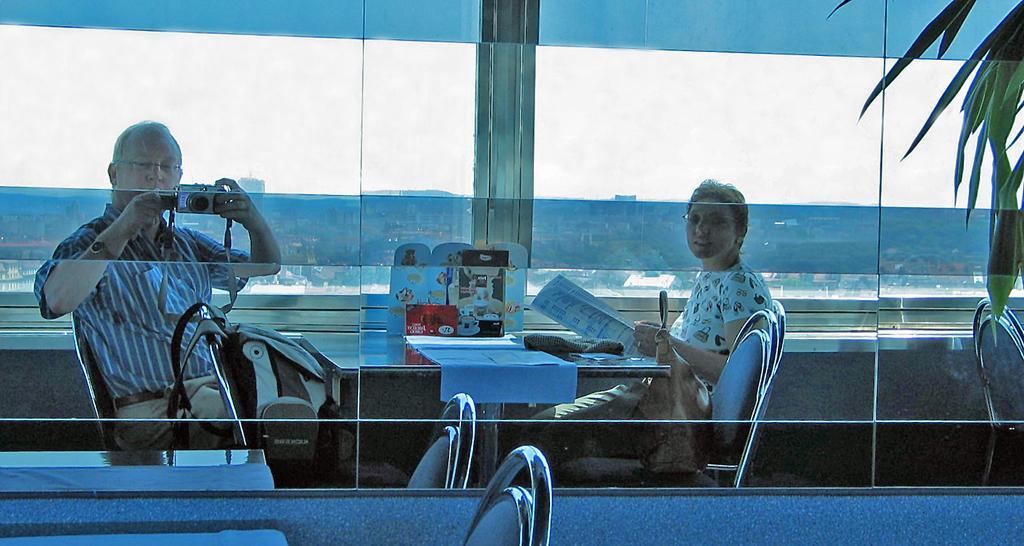Please provide a concise description of this image. In this image there are two people. There is a glass. There are chairs and tables. There is a camera. Behind the glass I think there are trees and houses. 